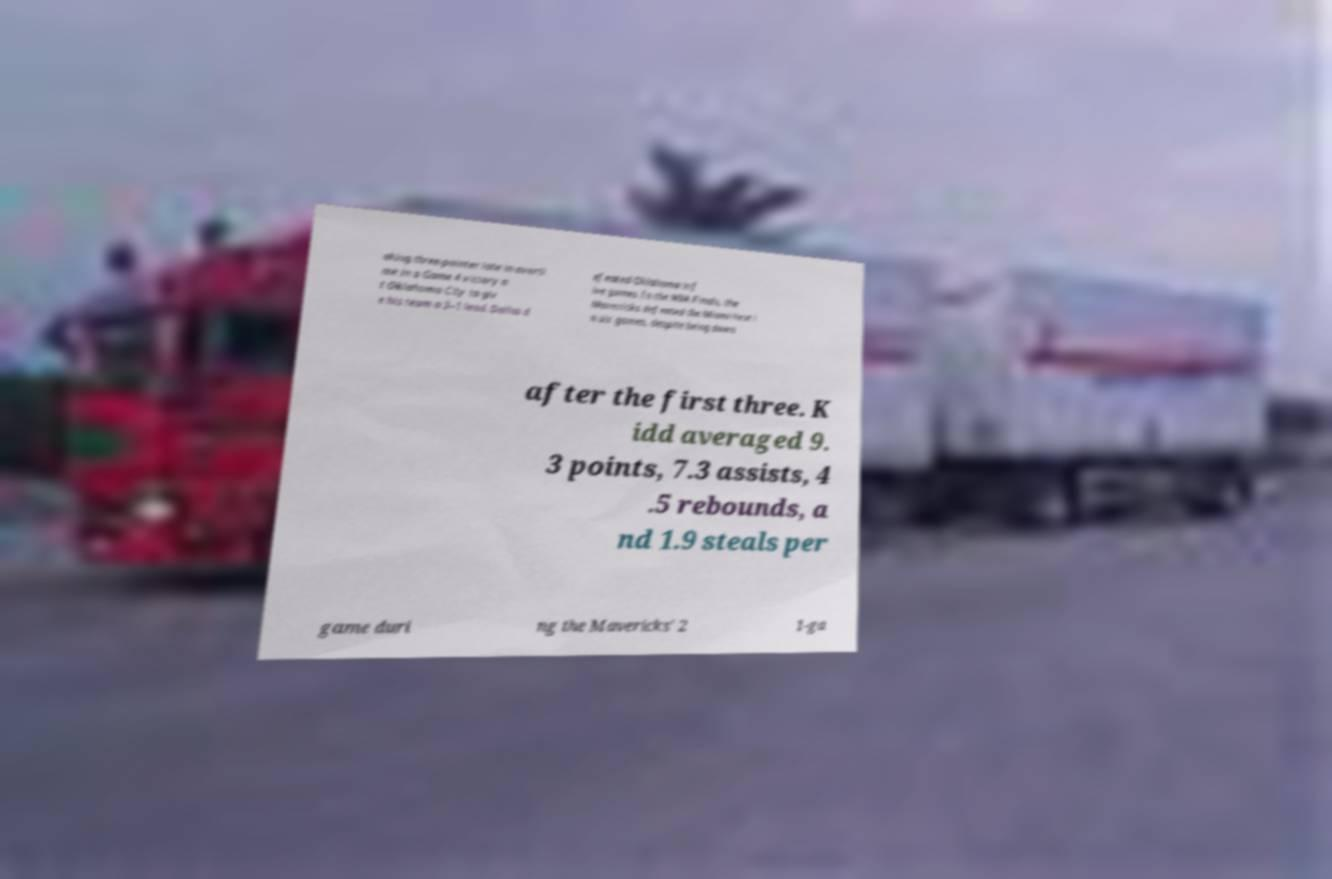Could you assist in decoding the text presented in this image and type it out clearly? aking three-pointer late in overti me in a Game 4 victory a t Oklahoma City to giv e his team a 3–1 lead. Dallas d efeated Oklahoma in f ive games. In the NBA Finals, the Mavericks defeated the Miami Heat i n six games, despite being down after the first three. K idd averaged 9. 3 points, 7.3 assists, 4 .5 rebounds, a nd 1.9 steals per game duri ng the Mavericks' 2 1-ga 